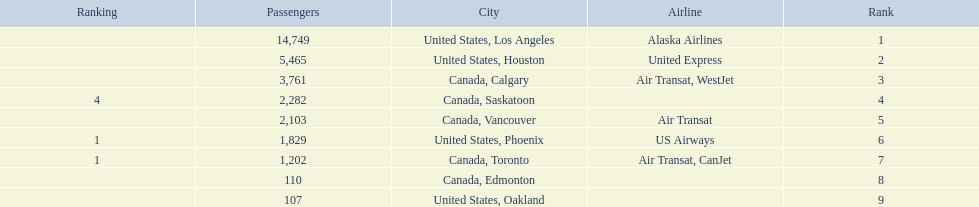What are the cities flown to? United States, Los Angeles, United States, Houston, Canada, Calgary, Canada, Saskatoon, Canada, Vancouver, United States, Phoenix, Canada, Toronto, Canada, Edmonton, United States, Oakland. What number of passengers did pheonix have? 1,829. 